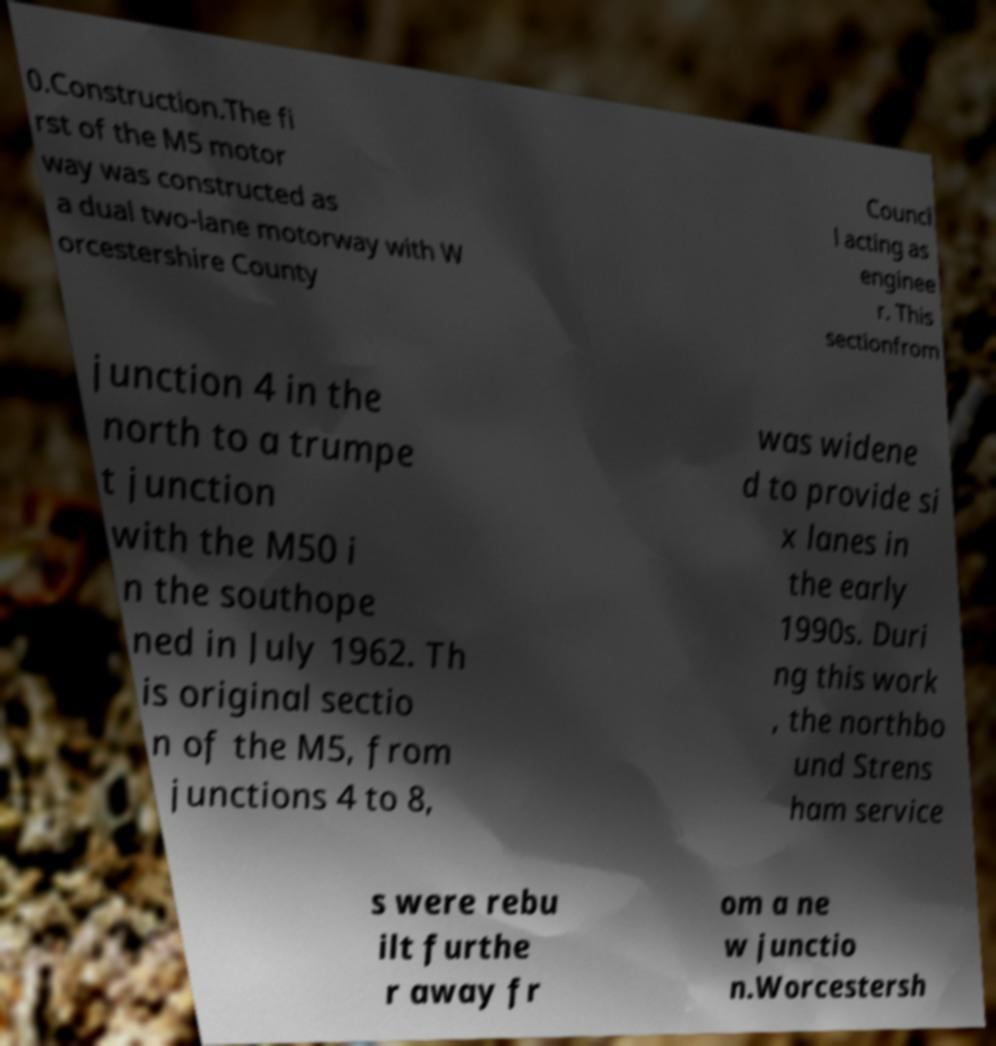I need the written content from this picture converted into text. Can you do that? 0.Construction.The fi rst of the M5 motor way was constructed as a dual two-lane motorway with W orcestershire County Counci l acting as enginee r. This sectionfrom junction 4 in the north to a trumpe t junction with the M50 i n the southope ned in July 1962. Th is original sectio n of the M5, from junctions 4 to 8, was widene d to provide si x lanes in the early 1990s. Duri ng this work , the northbo und Strens ham service s were rebu ilt furthe r away fr om a ne w junctio n.Worcestersh 